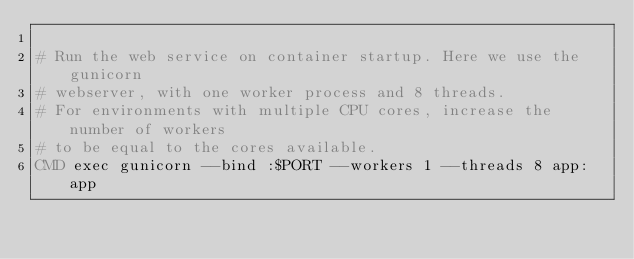<code> <loc_0><loc_0><loc_500><loc_500><_Dockerfile_>
# Run the web service on container startup. Here we use the gunicorn
# webserver, with one worker process and 8 threads.
# For environments with multiple CPU cores, increase the number of workers
# to be equal to the cores available.
CMD exec gunicorn --bind :$PORT --workers 1 --threads 8 app:app</code> 